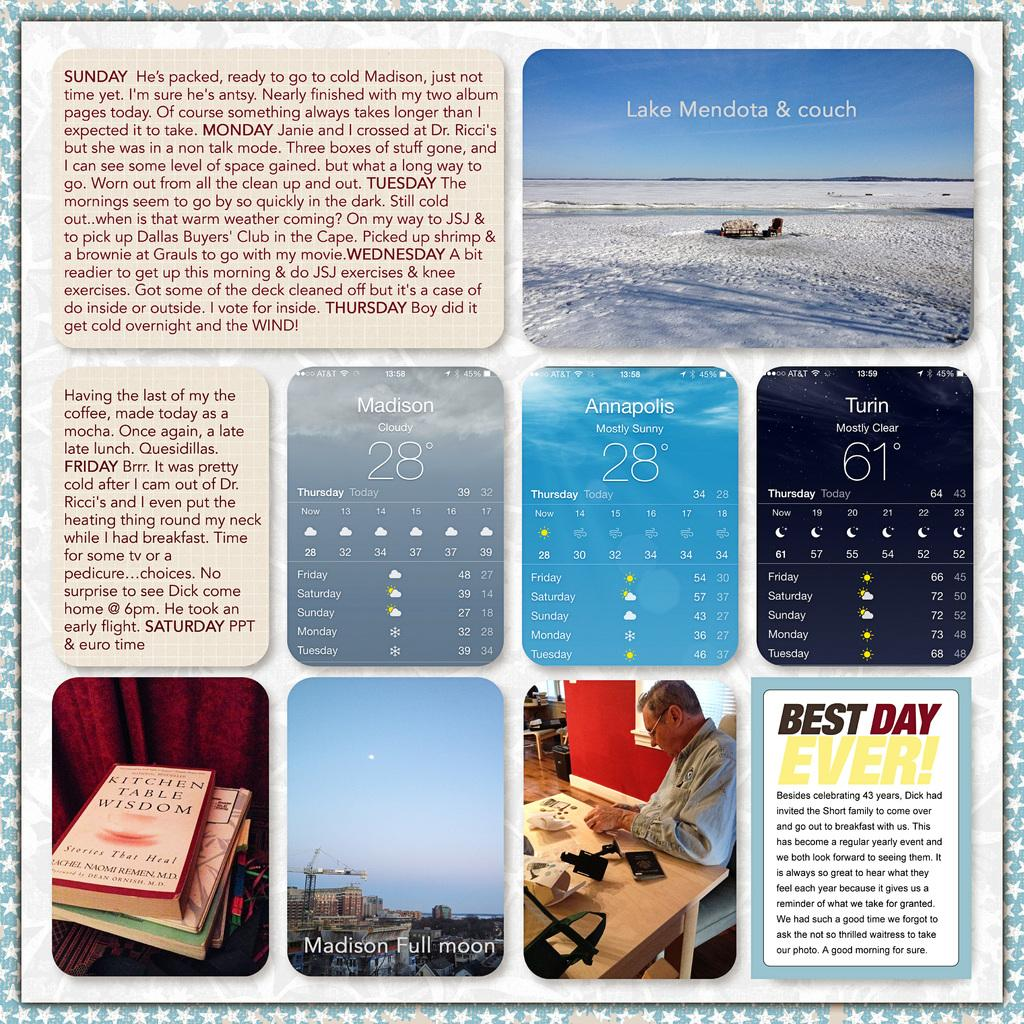<image>
Describe the image concisely. Different images are shown of a man's activities to celebrate his 43rd birthday in Madison. 